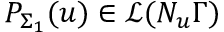<formula> <loc_0><loc_0><loc_500><loc_500>P _ { \Sigma _ { 1 } } ( u ) \in \mathcal { L } ( N _ { u } \Gamma )</formula> 